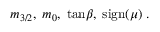Convert formula to latex. <formula><loc_0><loc_0><loc_500><loc_500>m _ { 3 / 2 } , \, m _ { 0 } , \, t a n \beta , \, s i g n ( \mu ) \, .</formula> 